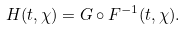Convert formula to latex. <formula><loc_0><loc_0><loc_500><loc_500>H ( t , \chi ) = G \circ F ^ { - 1 } ( t , \chi ) .</formula> 